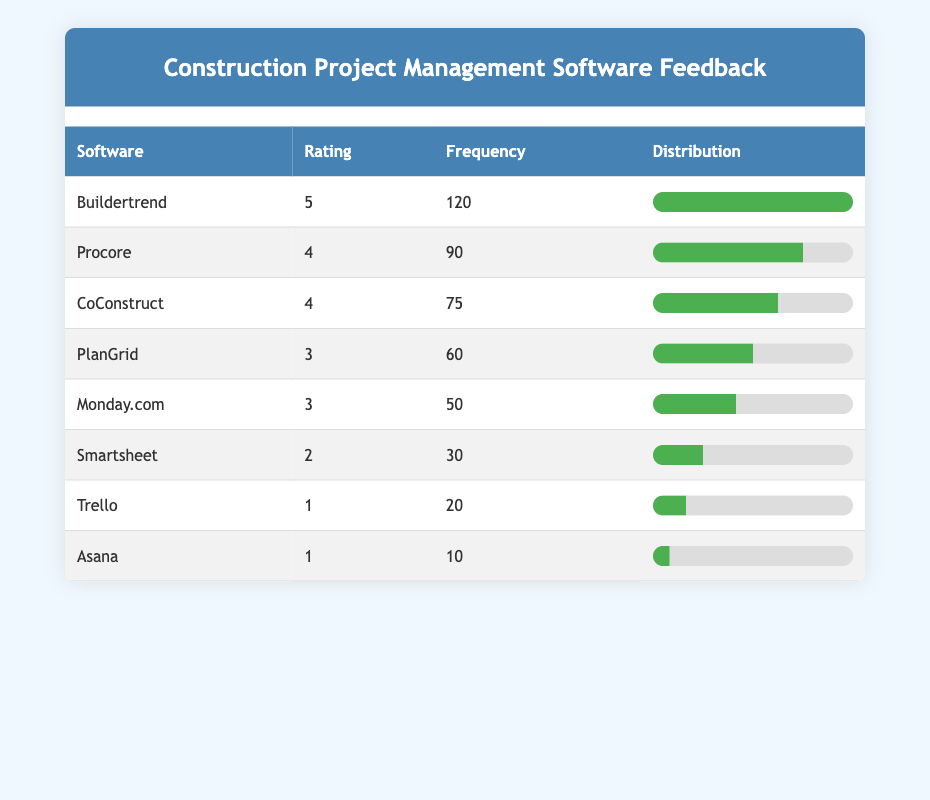What software received the highest rating? The table shows that Buildertrend has a rating of 5, which is the highest rating among all software listed.
Answer: Buildertrend How many users rated Procore with a frequency of 90? According to the table, Procore has a frequency of 90, which means 90 users rated it.
Answer: 90 What is the total frequency of software that received a rating of 3? Summing the frequencies of PlanGrid (60) and Monday.com (50) gives us 60 + 50 = 110. Therefore, the total frequency for rating 3 is 110.
Answer: 110 Is Trello rated higher than Asana? Trello has a rating of 1 and Asana also has a rating of 1. Thus, neither is rated higher than the other; they are equal.
Answer: No Which software has the lowest frequency and what is that frequency? Looking at the table, Asana has the lowest frequency of 10 users.
Answer: Asana, 10 What is the average frequency of all software rated with a 4? To find the average frequency for software rated 4, we sum the frequencies of Procore (90) and CoConstruct (75) giving us 90 + 75 = 165. There are 2 entries, so the average is 165/2 = 82.5.
Answer: 82.5 Which software has a frequency greater than 100? Buildertrend has a frequency of 120, which is greater than 100. All other software have frequencies below 100.
Answer: Buildertrend What percentage of users rated Smartsheet with a frequency of 30 compared to the total frequency of all users? The total frequency is 120 + 90 + 75 + 60 + 50 + 30 + 20 + 10 = 455. To find the percentage of users who rated Smartsheet, we calculate (30/455) * 100 = 6.58%.
Answer: 6.58% 